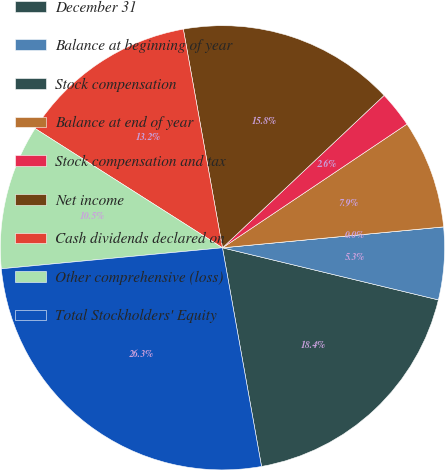Convert chart. <chart><loc_0><loc_0><loc_500><loc_500><pie_chart><fcel>December 31<fcel>Balance at beginning of year<fcel>Stock compensation<fcel>Balance at end of year<fcel>Stock compensation and tax<fcel>Net income<fcel>Cash dividends declared on<fcel>Other comprehensive (loss)<fcel>Total Stockholders' Equity<nl><fcel>18.42%<fcel>5.27%<fcel>0.0%<fcel>7.9%<fcel>2.63%<fcel>15.79%<fcel>13.16%<fcel>10.53%<fcel>26.31%<nl></chart> 